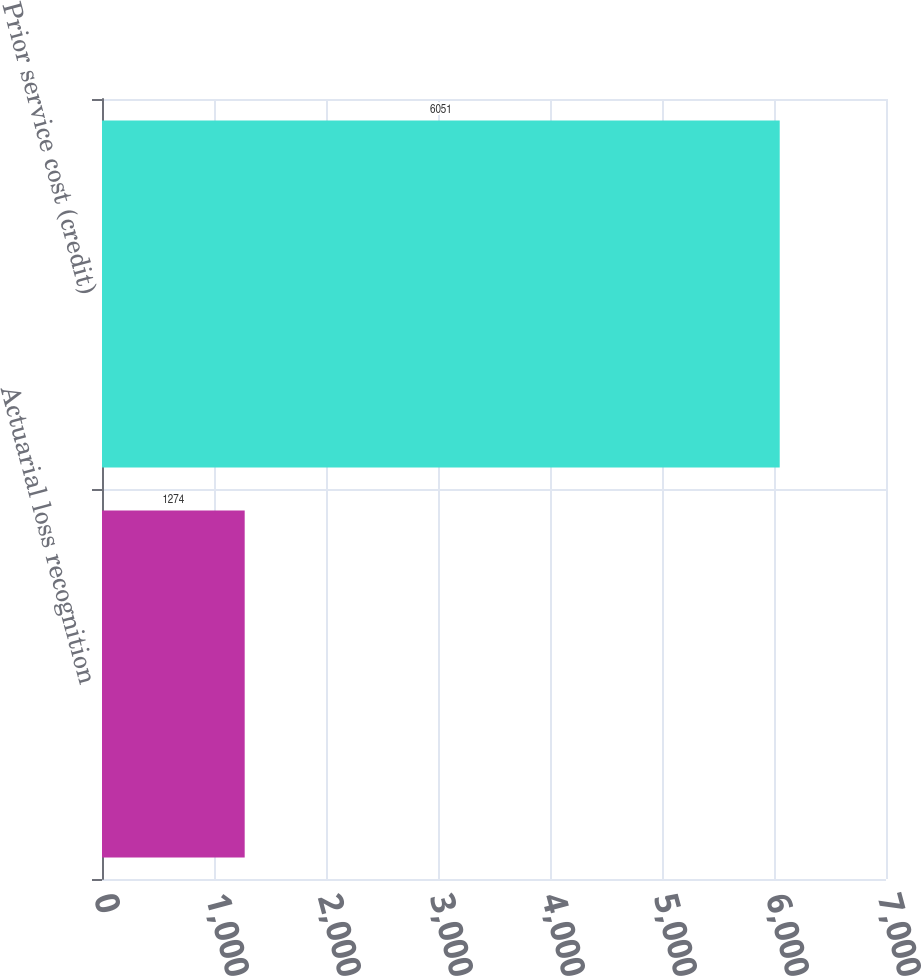<chart> <loc_0><loc_0><loc_500><loc_500><bar_chart><fcel>Actuarial loss recognition<fcel>Prior service cost (credit)<nl><fcel>1274<fcel>6051<nl></chart> 